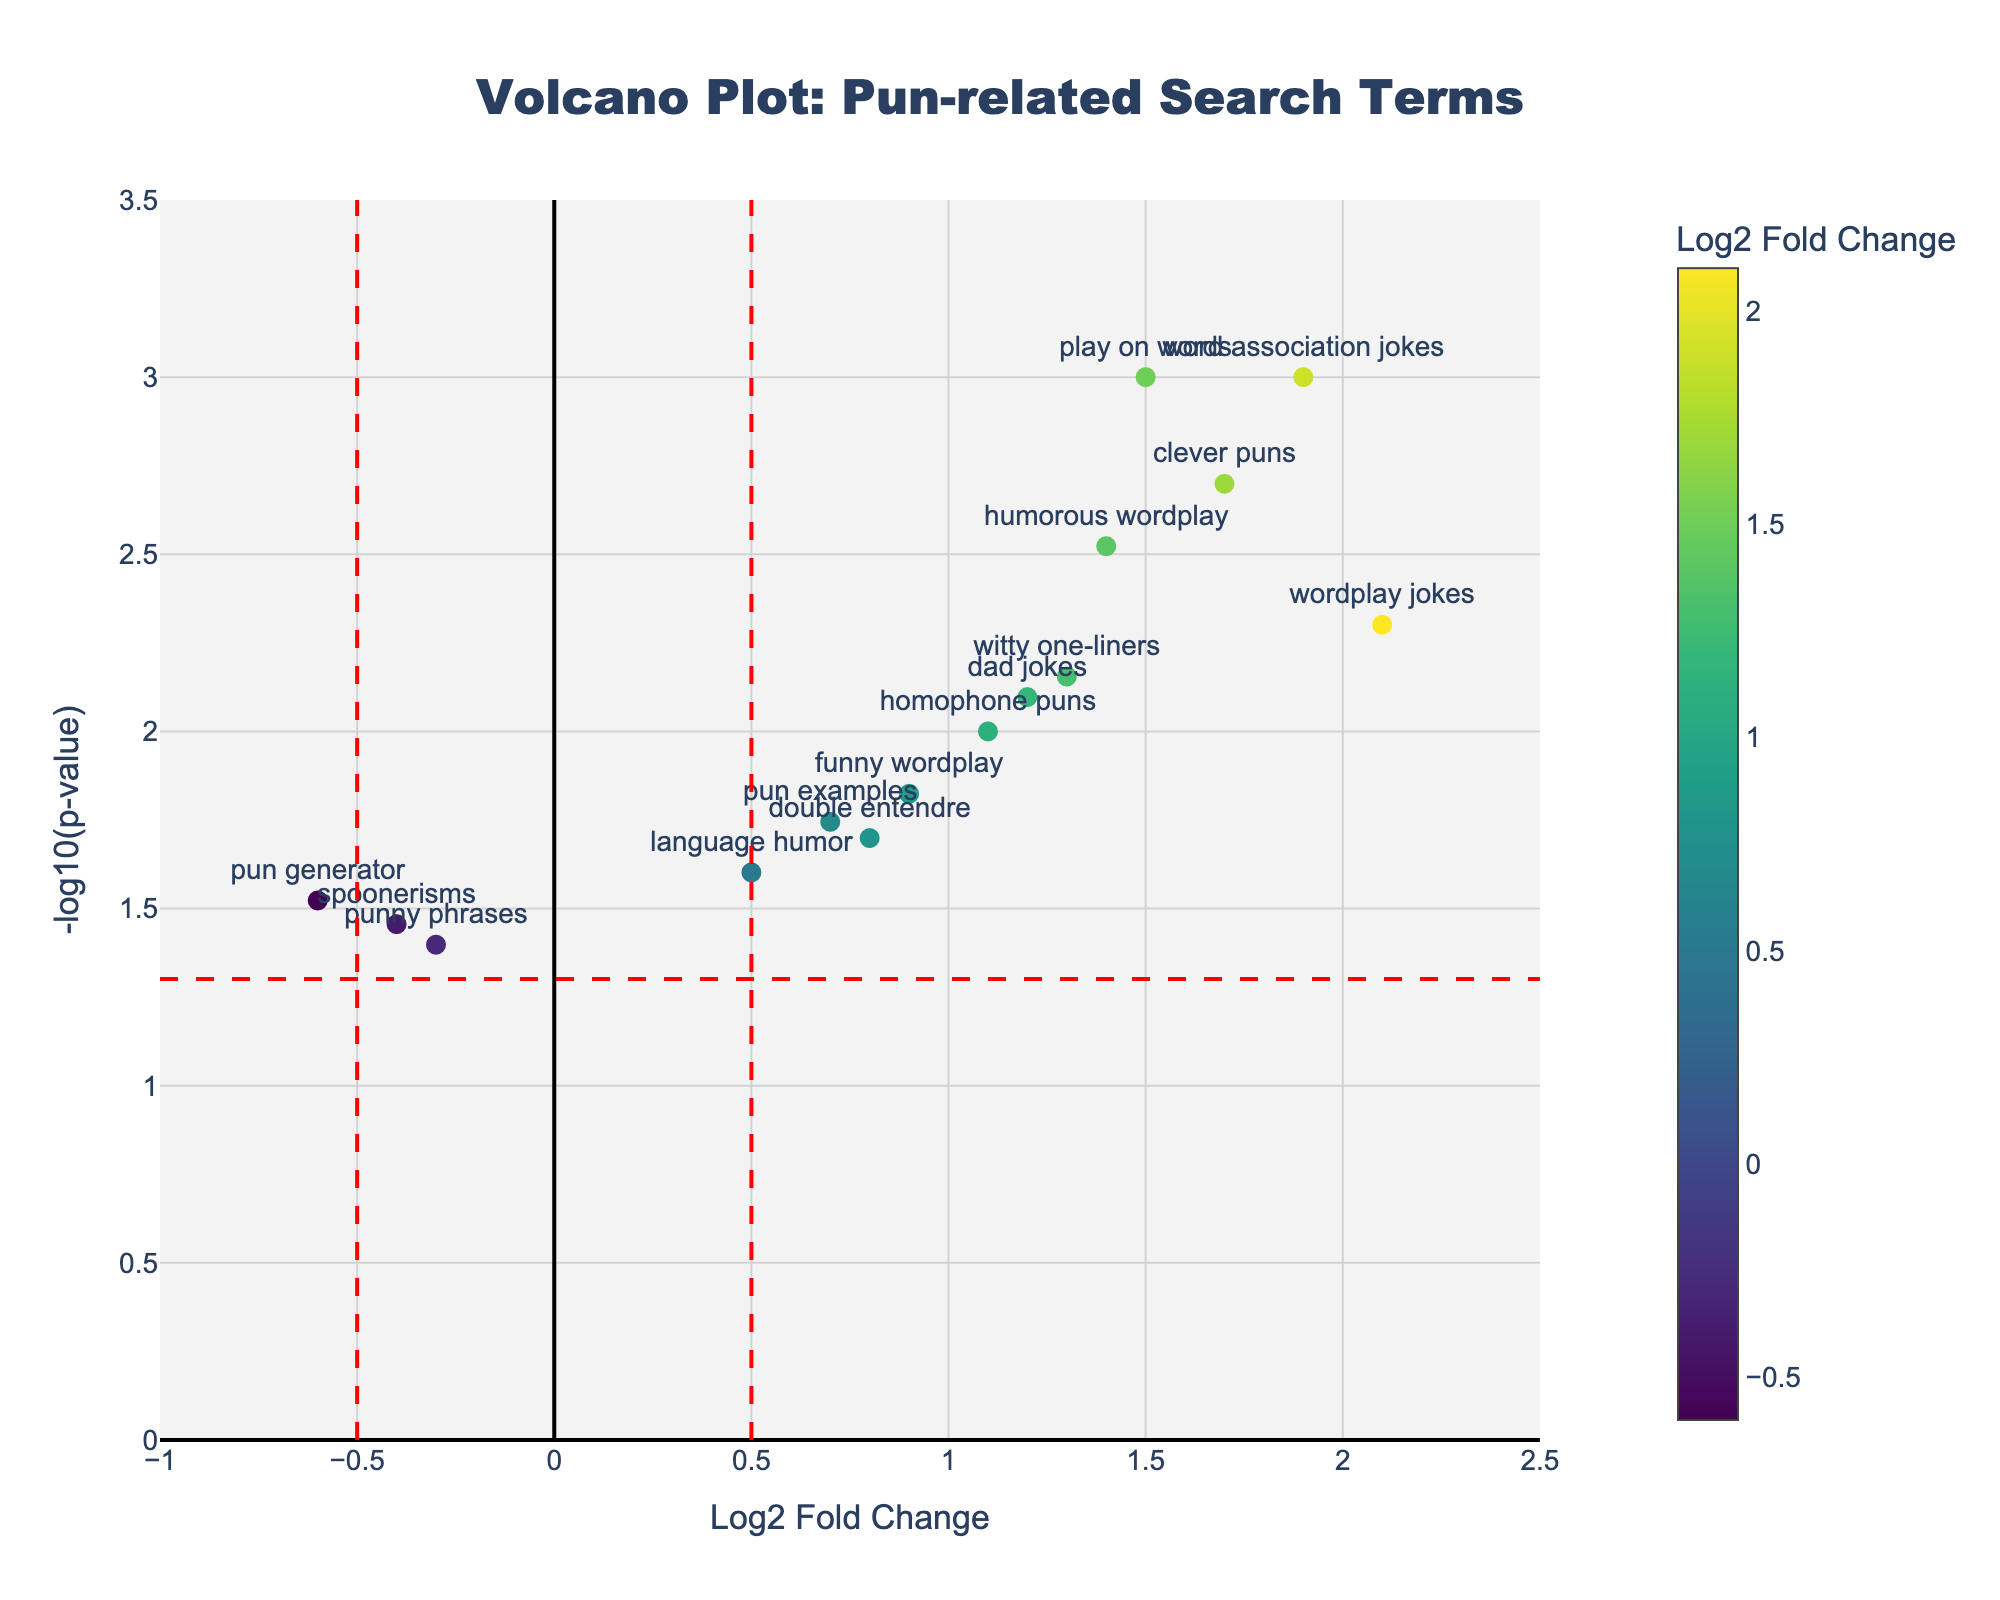What is the title of the plot? The title of the plot is usually displayed prominently at the top of a figure. In this case, the plot title is clearly written.
Answer: "Volcano Plot: Pun-related Search Terms" Which search term has the highest -log10(p-value)? To determine the search term with the highest -log10(p-value), look for the point with the highest y-coordinate on the plot.
Answer: "play on words" How many search terms have a log2 fold change greater than 1? Count the data points on the plot that are positioned to the right of the log2 fold change value of 1 on the x-axis.
Answer: 9 Which data point represents "pun generator"? Find the label "pun generator" on the plot. It should be near the corresponding point.
Answer: The point with a log2 fold change of -0.6 and a p-value of 0.03 What are the log2 fold change and p-value for "witty one-liners"? Locate the point labeled "witty one-liners" on the plot and read off the values from its position on the x and y axes.
Answer: Log2 FC: 1.3, p-value: 0.007 How many search terms appear above the threshold line for -log10(p-value) of 1.3? Count the data points that are above the horizontal threshold line indicating -log10(p-value) = 1.3, which corresponds to a p-value of approximately 0.05.
Answer: 6 Which search term has the lowest log2 fold change? Find the point furthest to the left on the x-axis, as this will have the lowest log2 fold change.
Answer: "pun generator" Which term has a log2 fold change between 0.5 and 1 and a -log10(p-value) below 2? Locate points within the specified range on both axes by visual inspection. There is one point that fits this criterion.
Answer: "language humor" What can be inferred about the "wordplay jokes" search term based on its position in the plot? The position in the plot reveals two aspects: its log2 fold change and its -log10(p-value). The higher the point and the further to the right, the more significant and increased the change is.
Answer: "wordplay jokes" has a high log2 fold change (2.1) and low p-value (0.005), indicating a significantly high increase Is "funny wordplay" considered significant based on the p-value threshold marked on the plot? Check if the point for "funny wordplay" is above the -log10(p-value) threshold line of 1.3, representing p = 0.05.
Answer: Yes 